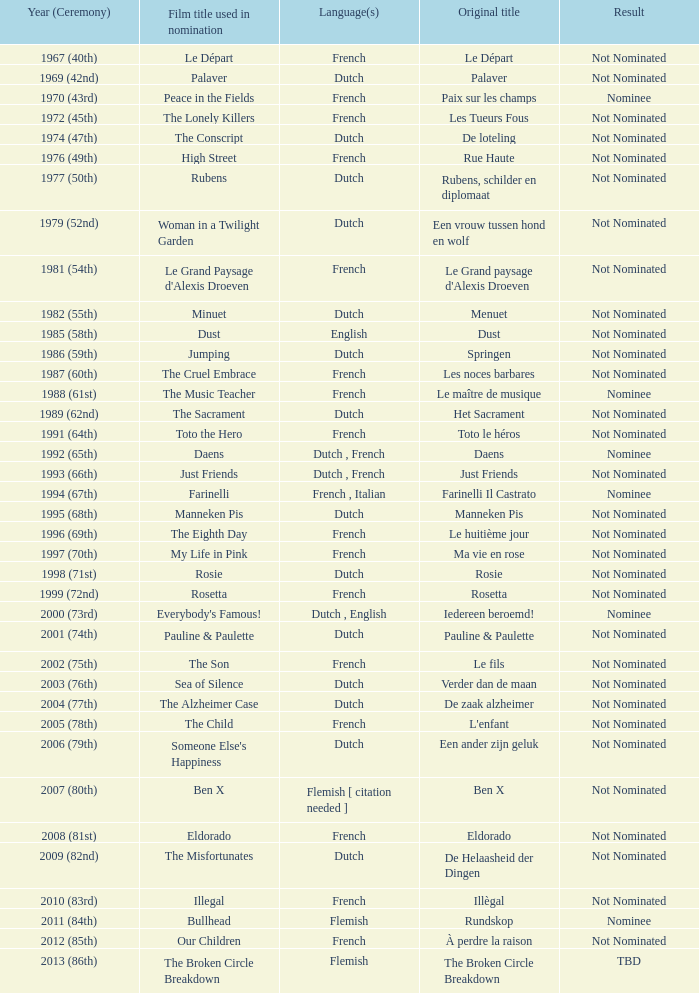Can you parse all the data within this table? {'header': ['Year (Ceremony)', 'Film title used in nomination', 'Language(s)', 'Original title', 'Result'], 'rows': [['1967 (40th)', 'Le Départ', 'French', 'Le Départ', 'Not Nominated'], ['1969 (42nd)', 'Palaver', 'Dutch', 'Palaver', 'Not Nominated'], ['1970 (43rd)', 'Peace in the Fields', 'French', 'Paix sur les champs', 'Nominee'], ['1972 (45th)', 'The Lonely Killers', 'French', 'Les Tueurs Fous', 'Not Nominated'], ['1974 (47th)', 'The Conscript', 'Dutch', 'De loteling', 'Not Nominated'], ['1976 (49th)', 'High Street', 'French', 'Rue Haute', 'Not Nominated'], ['1977 (50th)', 'Rubens', 'Dutch', 'Rubens, schilder en diplomaat', 'Not Nominated'], ['1979 (52nd)', 'Woman in a Twilight Garden', 'Dutch', 'Een vrouw tussen hond en wolf', 'Not Nominated'], ['1981 (54th)', "Le Grand Paysage d'Alexis Droeven", 'French', "Le Grand paysage d'Alexis Droeven", 'Not Nominated'], ['1982 (55th)', 'Minuet', 'Dutch', 'Menuet', 'Not Nominated'], ['1985 (58th)', 'Dust', 'English', 'Dust', 'Not Nominated'], ['1986 (59th)', 'Jumping', 'Dutch', 'Springen', 'Not Nominated'], ['1987 (60th)', 'The Cruel Embrace', 'French', 'Les noces barbares', 'Not Nominated'], ['1988 (61st)', 'The Music Teacher', 'French', 'Le maître de musique', 'Nominee'], ['1989 (62nd)', 'The Sacrament', 'Dutch', 'Het Sacrament', 'Not Nominated'], ['1991 (64th)', 'Toto the Hero', 'French', 'Toto le héros', 'Not Nominated'], ['1992 (65th)', 'Daens', 'Dutch , French', 'Daens', 'Nominee'], ['1993 (66th)', 'Just Friends', 'Dutch , French', 'Just Friends', 'Not Nominated'], ['1994 (67th)', 'Farinelli', 'French , Italian', 'Farinelli Il Castrato', 'Nominee'], ['1995 (68th)', 'Manneken Pis', 'Dutch', 'Manneken Pis', 'Not Nominated'], ['1996 (69th)', 'The Eighth Day', 'French', 'Le huitième jour', 'Not Nominated'], ['1997 (70th)', 'My Life in Pink', 'French', 'Ma vie en rose', 'Not Nominated'], ['1998 (71st)', 'Rosie', 'Dutch', 'Rosie', 'Not Nominated'], ['1999 (72nd)', 'Rosetta', 'French', 'Rosetta', 'Not Nominated'], ['2000 (73rd)', "Everybody's Famous!", 'Dutch , English', 'Iedereen beroemd!', 'Nominee'], ['2001 (74th)', 'Pauline & Paulette', 'Dutch', 'Pauline & Paulette', 'Not Nominated'], ['2002 (75th)', 'The Son', 'French', 'Le fils', 'Not Nominated'], ['2003 (76th)', 'Sea of Silence', 'Dutch', 'Verder dan de maan', 'Not Nominated'], ['2004 (77th)', 'The Alzheimer Case', 'Dutch', 'De zaak alzheimer', 'Not Nominated'], ['2005 (78th)', 'The Child', 'French', "L'enfant", 'Not Nominated'], ['2006 (79th)', "Someone Else's Happiness", 'Dutch', 'Een ander zijn geluk', 'Not Nominated'], ['2007 (80th)', 'Ben X', 'Flemish [ citation needed ]', 'Ben X', 'Not Nominated'], ['2008 (81st)', 'Eldorado', 'French', 'Eldorado', 'Not Nominated'], ['2009 (82nd)', 'The Misfortunates', 'Dutch', 'De Helaasheid der Dingen', 'Not Nominated'], ['2010 (83rd)', 'Illegal', 'French', 'Illègal', 'Not Nominated'], ['2011 (84th)', 'Bullhead', 'Flemish', 'Rundskop', 'Nominee'], ['2012 (85th)', 'Our Children', 'French', 'À perdre la raison', 'Not Nominated'], ['2013 (86th)', 'The Broken Circle Breakdown', 'Flemish', 'The Broken Circle Breakdown', 'TBD']]} What was the title used for Rosie, the film nominated for the dutch language? Rosie. 